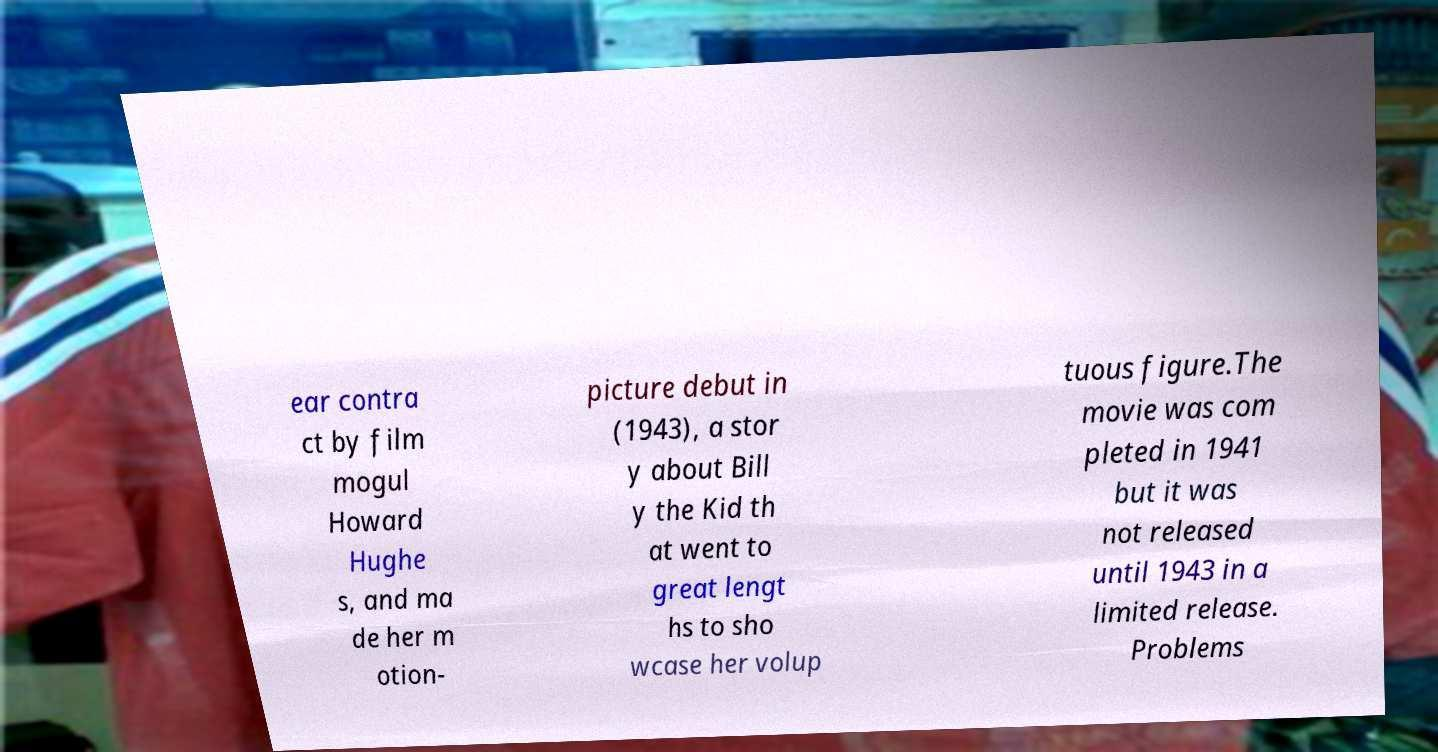Please read and relay the text visible in this image. What does it say? ear contra ct by film mogul Howard Hughe s, and ma de her m otion- picture debut in (1943), a stor y about Bill y the Kid th at went to great lengt hs to sho wcase her volup tuous figure.The movie was com pleted in 1941 but it was not released until 1943 in a limited release. Problems 